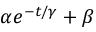Convert formula to latex. <formula><loc_0><loc_0><loc_500><loc_500>\alpha e ^ { - t / \gamma } + \beta</formula> 